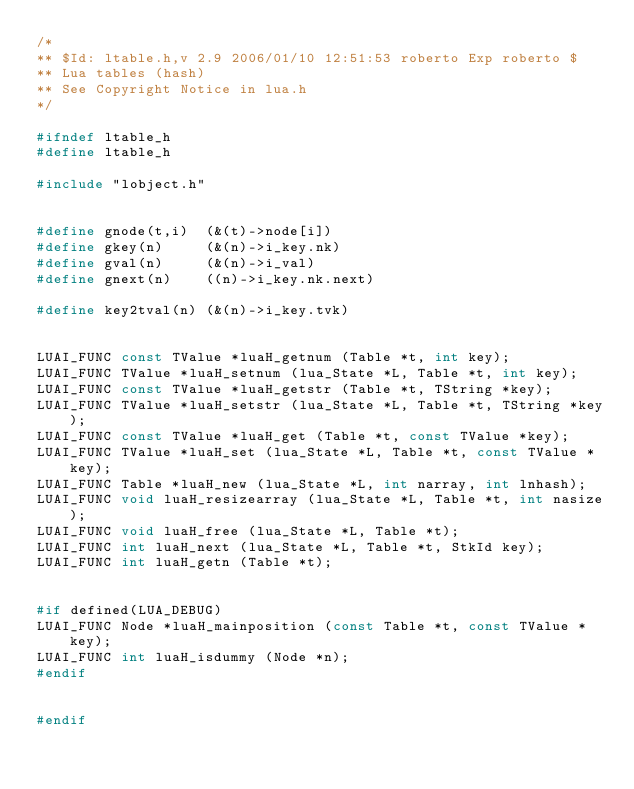<code> <loc_0><loc_0><loc_500><loc_500><_C_>/*
** $Id: ltable.h,v 2.9 2006/01/10 12:51:53 roberto Exp roberto $
** Lua tables (hash)
** See Copyright Notice in lua.h
*/

#ifndef ltable_h
#define ltable_h

#include "lobject.h"


#define gnode(t,i)	(&(t)->node[i])
#define gkey(n)		(&(n)->i_key.nk)
#define gval(n)		(&(n)->i_val)
#define gnext(n)	((n)->i_key.nk.next)

#define key2tval(n)	(&(n)->i_key.tvk)


LUAI_FUNC const TValue *luaH_getnum (Table *t, int key);
LUAI_FUNC TValue *luaH_setnum (lua_State *L, Table *t, int key);
LUAI_FUNC const TValue *luaH_getstr (Table *t, TString *key);
LUAI_FUNC TValue *luaH_setstr (lua_State *L, Table *t, TString *key);
LUAI_FUNC const TValue *luaH_get (Table *t, const TValue *key);
LUAI_FUNC TValue *luaH_set (lua_State *L, Table *t, const TValue *key);
LUAI_FUNC Table *luaH_new (lua_State *L, int narray, int lnhash);
LUAI_FUNC void luaH_resizearray (lua_State *L, Table *t, int nasize);
LUAI_FUNC void luaH_free (lua_State *L, Table *t);
LUAI_FUNC int luaH_next (lua_State *L, Table *t, StkId key);
LUAI_FUNC int luaH_getn (Table *t);


#if defined(LUA_DEBUG)
LUAI_FUNC Node *luaH_mainposition (const Table *t, const TValue *key);
LUAI_FUNC int luaH_isdummy (Node *n);
#endif


#endif
</code> 